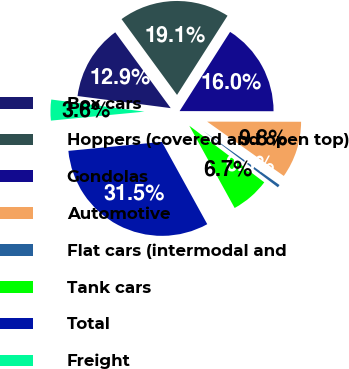<chart> <loc_0><loc_0><loc_500><loc_500><pie_chart><fcel>Box cars<fcel>Hoppers (covered and open top)<fcel>Gondolas<fcel>Automotive<fcel>Flat cars (intermodal and<fcel>Tank cars<fcel>Total<fcel>Freight<nl><fcel>12.89%<fcel>19.09%<fcel>15.99%<fcel>9.79%<fcel>0.48%<fcel>6.69%<fcel>31.5%<fcel>3.58%<nl></chart> 